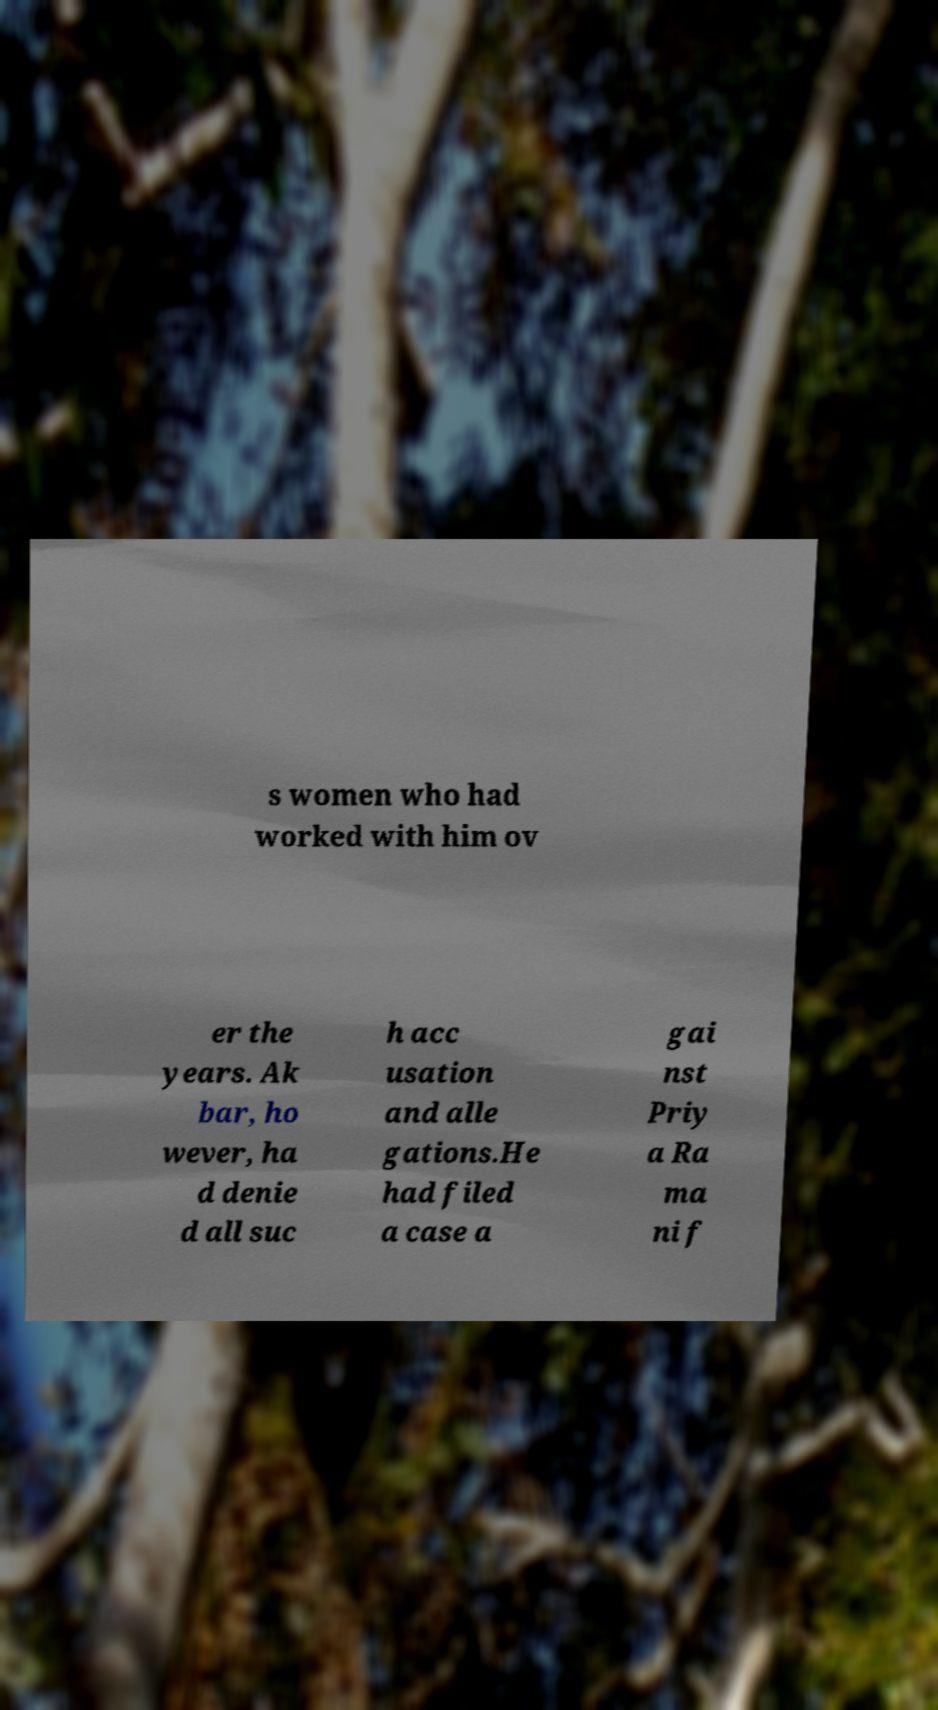Can you accurately transcribe the text from the provided image for me? s women who had worked with him ov er the years. Ak bar, ho wever, ha d denie d all suc h acc usation and alle gations.He had filed a case a gai nst Priy a Ra ma ni f 